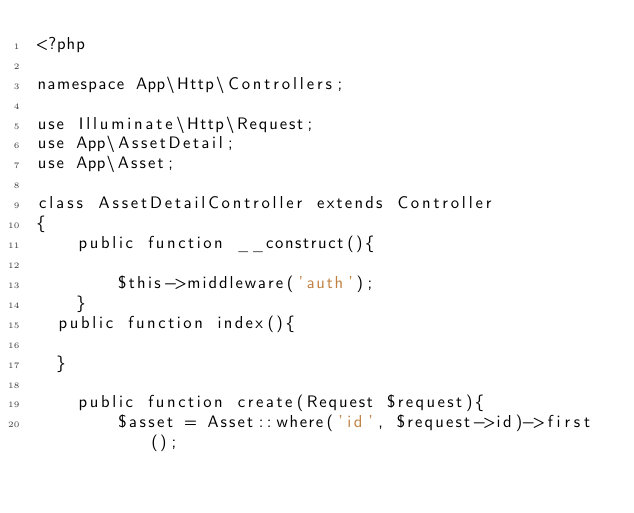Convert code to text. <code><loc_0><loc_0><loc_500><loc_500><_PHP_><?php

namespace App\Http\Controllers;

use Illuminate\Http\Request;
use App\AssetDetail;
use App\Asset;

class AssetDetailController extends Controller
{
    public function __construct(){

        $this->middleware('auth');
    }
	public function index(){

	}

    public function create(Request $request){
        $asset = Asset::where('id', $request->id)->first();</code> 